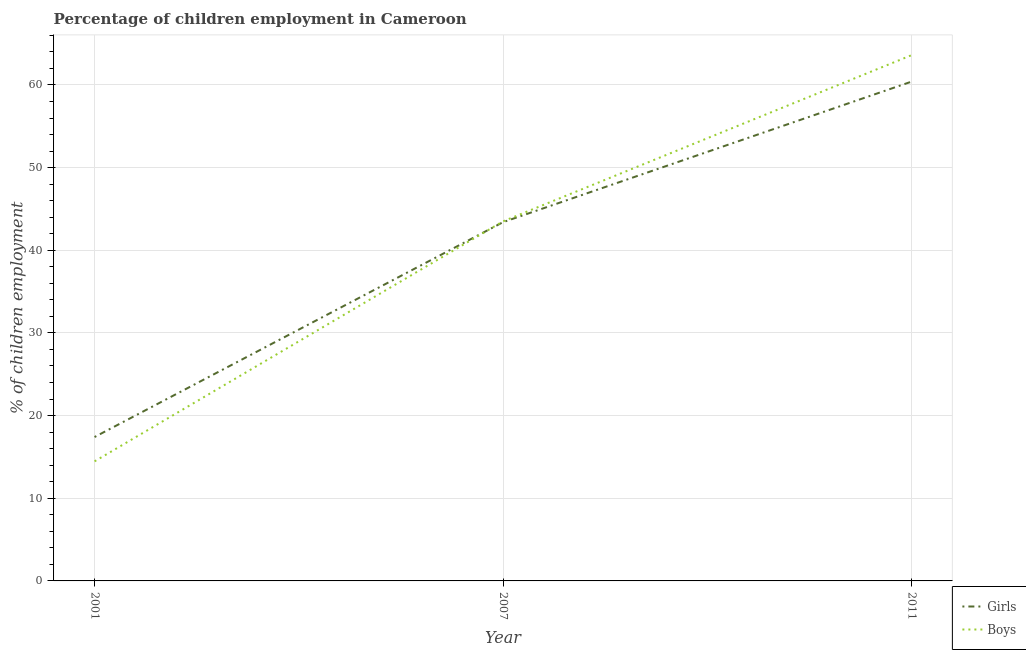What is the percentage of employed girls in 2001?
Give a very brief answer. 17.41. Across all years, what is the maximum percentage of employed boys?
Keep it short and to the point. 63.6. Across all years, what is the minimum percentage of employed boys?
Give a very brief answer. 14.47. In which year was the percentage of employed girls maximum?
Keep it short and to the point. 2011. In which year was the percentage of employed boys minimum?
Your response must be concise. 2001. What is the total percentage of employed girls in the graph?
Provide a succinct answer. 121.21. What is the difference between the percentage of employed boys in 2007 and that in 2011?
Keep it short and to the point. -20.1. What is the difference between the percentage of employed girls in 2011 and the percentage of employed boys in 2001?
Your answer should be very brief. 45.93. What is the average percentage of employed boys per year?
Keep it short and to the point. 40.52. In the year 2011, what is the difference between the percentage of employed girls and percentage of employed boys?
Your response must be concise. -3.2. In how many years, is the percentage of employed girls greater than 30 %?
Your answer should be compact. 2. What is the ratio of the percentage of employed boys in 2007 to that in 2011?
Offer a very short reply. 0.68. Is the difference between the percentage of employed girls in 2001 and 2011 greater than the difference between the percentage of employed boys in 2001 and 2011?
Your answer should be very brief. Yes. What is the difference between the highest and the second highest percentage of employed boys?
Offer a very short reply. 20.1. What is the difference between the highest and the lowest percentage of employed boys?
Give a very brief answer. 49.13. In how many years, is the percentage of employed girls greater than the average percentage of employed girls taken over all years?
Provide a short and direct response. 2. Is the percentage of employed girls strictly greater than the percentage of employed boys over the years?
Your answer should be very brief. No. What is the difference between two consecutive major ticks on the Y-axis?
Your response must be concise. 10. Does the graph contain any zero values?
Your answer should be compact. No. Does the graph contain grids?
Provide a short and direct response. Yes. How many legend labels are there?
Make the answer very short. 2. How are the legend labels stacked?
Give a very brief answer. Vertical. What is the title of the graph?
Provide a succinct answer. Percentage of children employment in Cameroon. What is the label or title of the Y-axis?
Offer a very short reply. % of children employment. What is the % of children employment in Girls in 2001?
Give a very brief answer. 17.41. What is the % of children employment in Boys in 2001?
Ensure brevity in your answer.  14.47. What is the % of children employment in Girls in 2007?
Make the answer very short. 43.4. What is the % of children employment in Boys in 2007?
Offer a very short reply. 43.5. What is the % of children employment in Girls in 2011?
Your answer should be very brief. 60.4. What is the % of children employment of Boys in 2011?
Ensure brevity in your answer.  63.6. Across all years, what is the maximum % of children employment in Girls?
Your response must be concise. 60.4. Across all years, what is the maximum % of children employment of Boys?
Provide a short and direct response. 63.6. Across all years, what is the minimum % of children employment of Girls?
Your answer should be very brief. 17.41. Across all years, what is the minimum % of children employment in Boys?
Offer a very short reply. 14.47. What is the total % of children employment in Girls in the graph?
Make the answer very short. 121.21. What is the total % of children employment in Boys in the graph?
Your answer should be very brief. 121.57. What is the difference between the % of children employment of Girls in 2001 and that in 2007?
Offer a terse response. -25.99. What is the difference between the % of children employment of Boys in 2001 and that in 2007?
Offer a terse response. -29.03. What is the difference between the % of children employment in Girls in 2001 and that in 2011?
Your answer should be compact. -42.99. What is the difference between the % of children employment of Boys in 2001 and that in 2011?
Make the answer very short. -49.13. What is the difference between the % of children employment of Boys in 2007 and that in 2011?
Give a very brief answer. -20.1. What is the difference between the % of children employment in Girls in 2001 and the % of children employment in Boys in 2007?
Your answer should be compact. -26.09. What is the difference between the % of children employment of Girls in 2001 and the % of children employment of Boys in 2011?
Your answer should be very brief. -46.19. What is the difference between the % of children employment in Girls in 2007 and the % of children employment in Boys in 2011?
Offer a terse response. -20.2. What is the average % of children employment in Girls per year?
Provide a succinct answer. 40.4. What is the average % of children employment in Boys per year?
Provide a succinct answer. 40.52. In the year 2001, what is the difference between the % of children employment of Girls and % of children employment of Boys?
Your answer should be compact. 2.94. In the year 2007, what is the difference between the % of children employment in Girls and % of children employment in Boys?
Offer a very short reply. -0.1. In the year 2011, what is the difference between the % of children employment in Girls and % of children employment in Boys?
Keep it short and to the point. -3.2. What is the ratio of the % of children employment of Girls in 2001 to that in 2007?
Offer a very short reply. 0.4. What is the ratio of the % of children employment in Boys in 2001 to that in 2007?
Offer a terse response. 0.33. What is the ratio of the % of children employment of Girls in 2001 to that in 2011?
Your answer should be compact. 0.29. What is the ratio of the % of children employment of Boys in 2001 to that in 2011?
Make the answer very short. 0.23. What is the ratio of the % of children employment in Girls in 2007 to that in 2011?
Keep it short and to the point. 0.72. What is the ratio of the % of children employment in Boys in 2007 to that in 2011?
Give a very brief answer. 0.68. What is the difference between the highest and the second highest % of children employment in Girls?
Give a very brief answer. 17. What is the difference between the highest and the second highest % of children employment of Boys?
Provide a short and direct response. 20.1. What is the difference between the highest and the lowest % of children employment in Girls?
Provide a short and direct response. 42.99. What is the difference between the highest and the lowest % of children employment in Boys?
Provide a succinct answer. 49.13. 